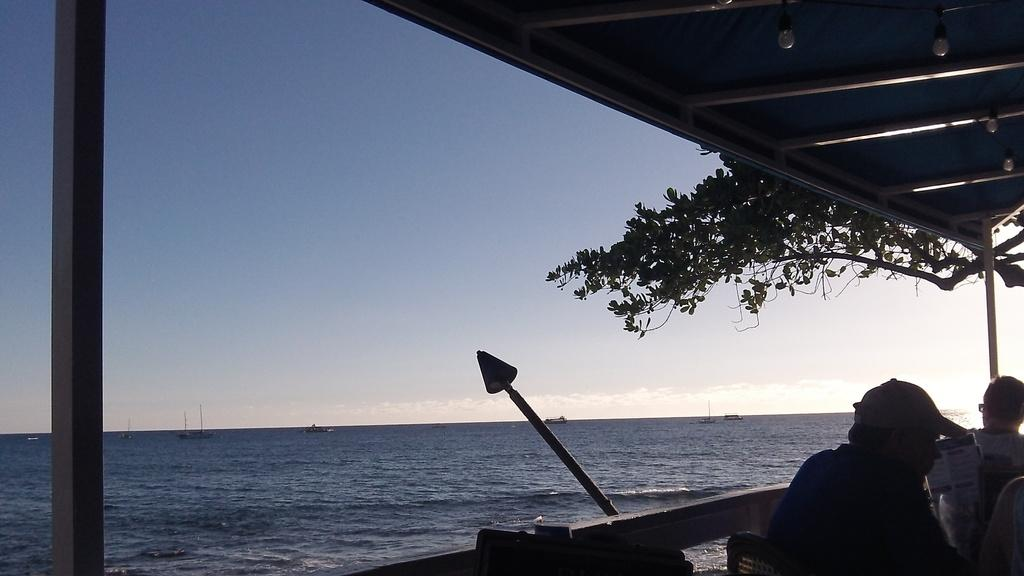How many people are in the image? There are persons in the image, but the exact number is not specified. What is located near the water in the image? There is a tree in the image. What is floating on the water in the image? There are boats on the surface of the water. What can be seen in the background of the image? The sky is visible in the background of the image. What type of ball is being used by the girl in the image? There is no girl or ball present in the image. 